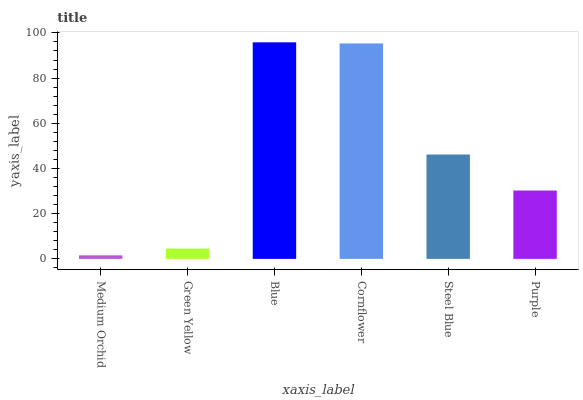Is Green Yellow the minimum?
Answer yes or no. No. Is Green Yellow the maximum?
Answer yes or no. No. Is Green Yellow greater than Medium Orchid?
Answer yes or no. Yes. Is Medium Orchid less than Green Yellow?
Answer yes or no. Yes. Is Medium Orchid greater than Green Yellow?
Answer yes or no. No. Is Green Yellow less than Medium Orchid?
Answer yes or no. No. Is Steel Blue the high median?
Answer yes or no. Yes. Is Purple the low median?
Answer yes or no. Yes. Is Blue the high median?
Answer yes or no. No. Is Medium Orchid the low median?
Answer yes or no. No. 